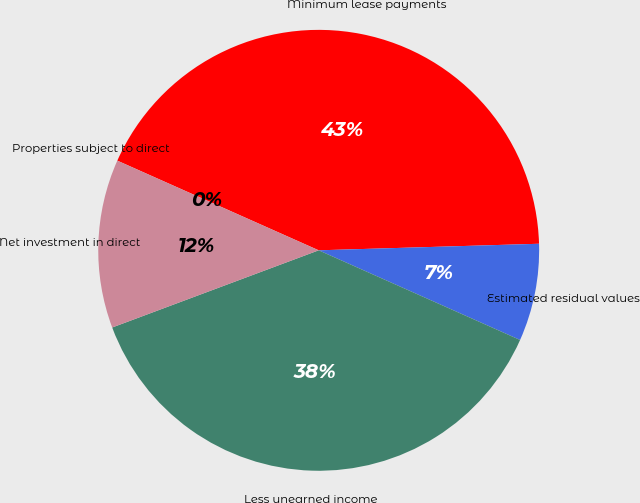Convert chart to OTSL. <chart><loc_0><loc_0><loc_500><loc_500><pie_chart><fcel>Minimum lease payments<fcel>Estimated residual values<fcel>Less unearned income<fcel>Net investment in direct<fcel>Properties subject to direct<nl><fcel>42.86%<fcel>7.14%<fcel>37.64%<fcel>12.36%<fcel>0.0%<nl></chart> 